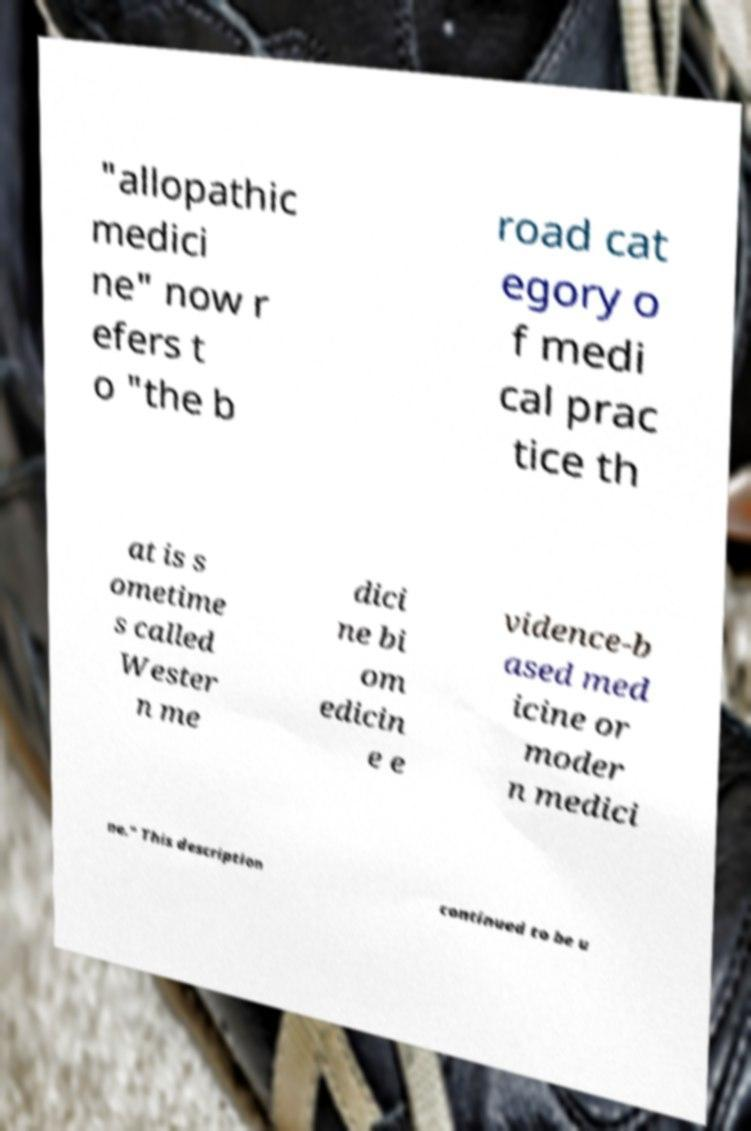Please identify and transcribe the text found in this image. "allopathic medici ne" now r efers t o "the b road cat egory o f medi cal prac tice th at is s ometime s called Wester n me dici ne bi om edicin e e vidence-b ased med icine or moder n medici ne." This description continued to be u 